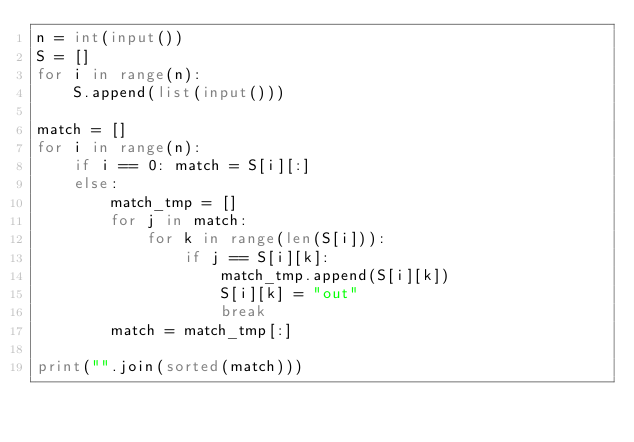<code> <loc_0><loc_0><loc_500><loc_500><_Python_>n = int(input())
S = []
for i in range(n):
    S.append(list(input()))

match = []
for i in range(n):
    if i == 0: match = S[i][:]
    else:
        match_tmp = []
        for j in match:
            for k in range(len(S[i])):
                if j == S[i][k]:
                    match_tmp.append(S[i][k])
                    S[i][k] = "out"
                    break
        match = match_tmp[:]

print("".join(sorted(match)))
</code> 